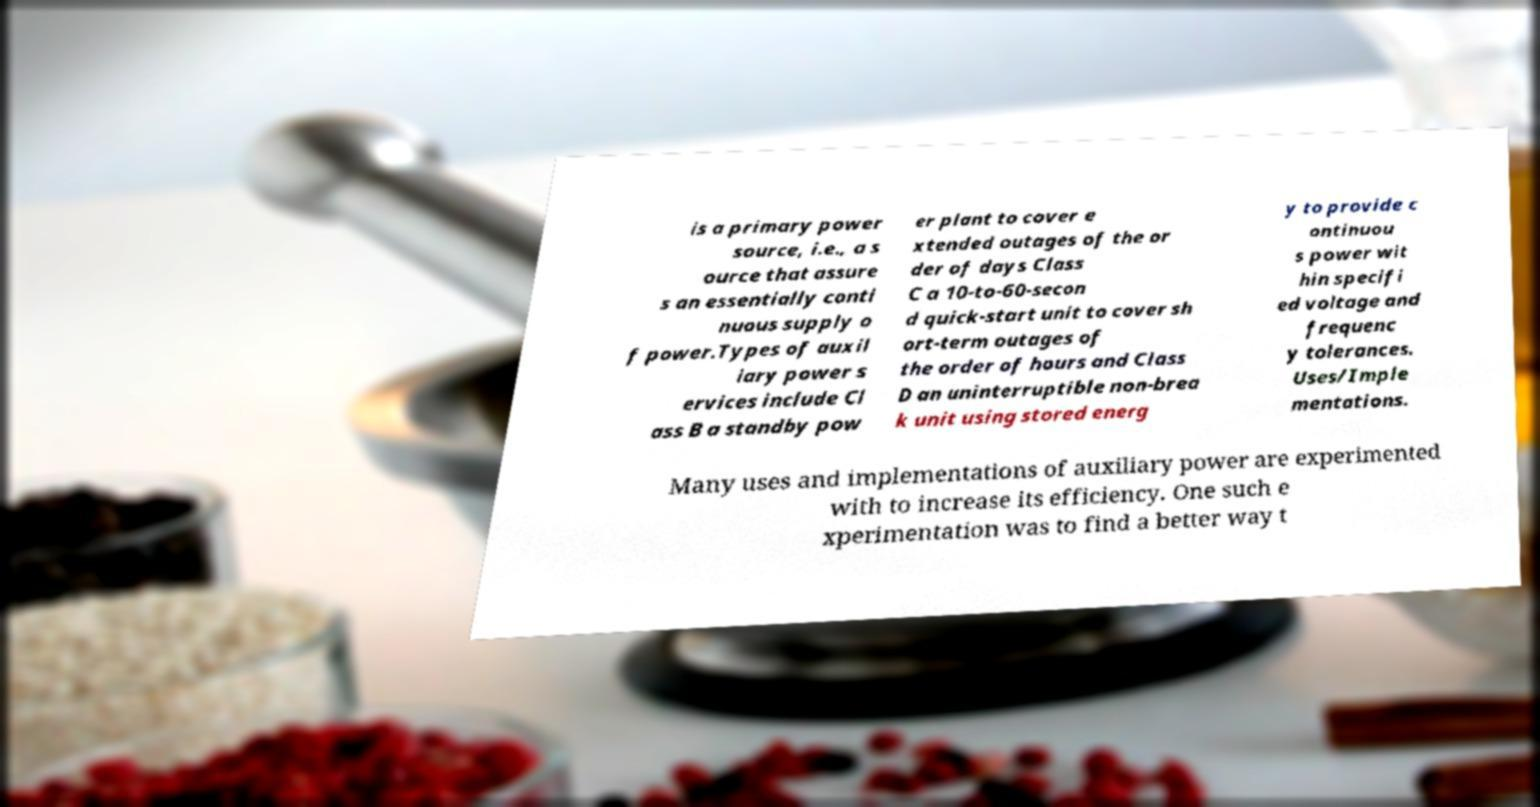Can you accurately transcribe the text from the provided image for me? is a primary power source, i.e., a s ource that assure s an essentially conti nuous supply o f power.Types of auxil iary power s ervices include Cl ass B a standby pow er plant to cover e xtended outages of the or der of days Class C a 10-to-60-secon d quick-start unit to cover sh ort-term outages of the order of hours and Class D an uninterruptible non-brea k unit using stored energ y to provide c ontinuou s power wit hin specifi ed voltage and frequenc y tolerances. Uses/Imple mentations. Many uses and implementations of auxiliary power are experimented with to increase its efficiency. One such e xperimentation was to find a better way t 